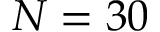<formula> <loc_0><loc_0><loc_500><loc_500>N = 3 0</formula> 